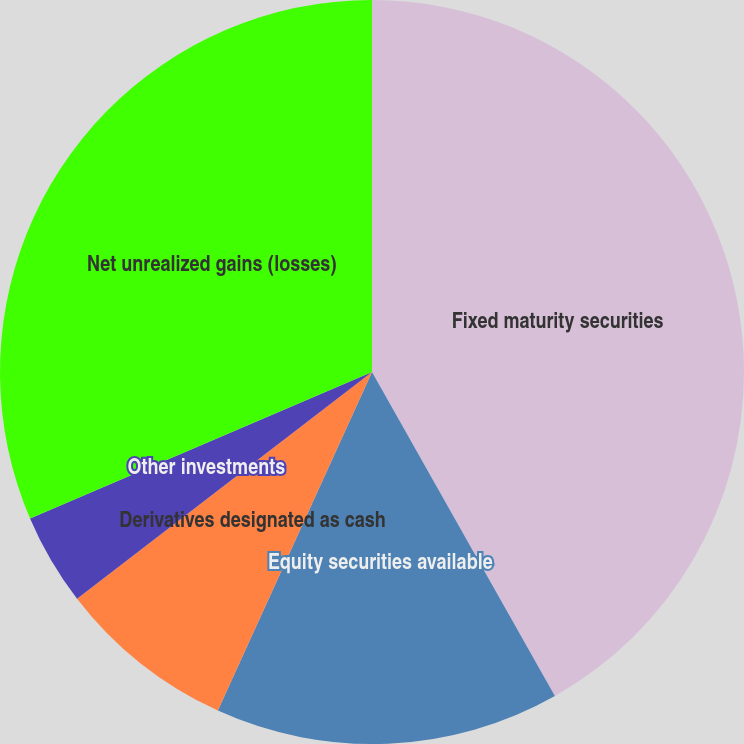Convert chart. <chart><loc_0><loc_0><loc_500><loc_500><pie_chart><fcel>Fixed maturity securities<fcel>Equity securities available<fcel>Derivatives designated as cash<fcel>Other investments<fcel>Net unrealized gains (losses)<nl><fcel>41.82%<fcel>14.98%<fcel>7.77%<fcel>3.99%<fcel>31.44%<nl></chart> 